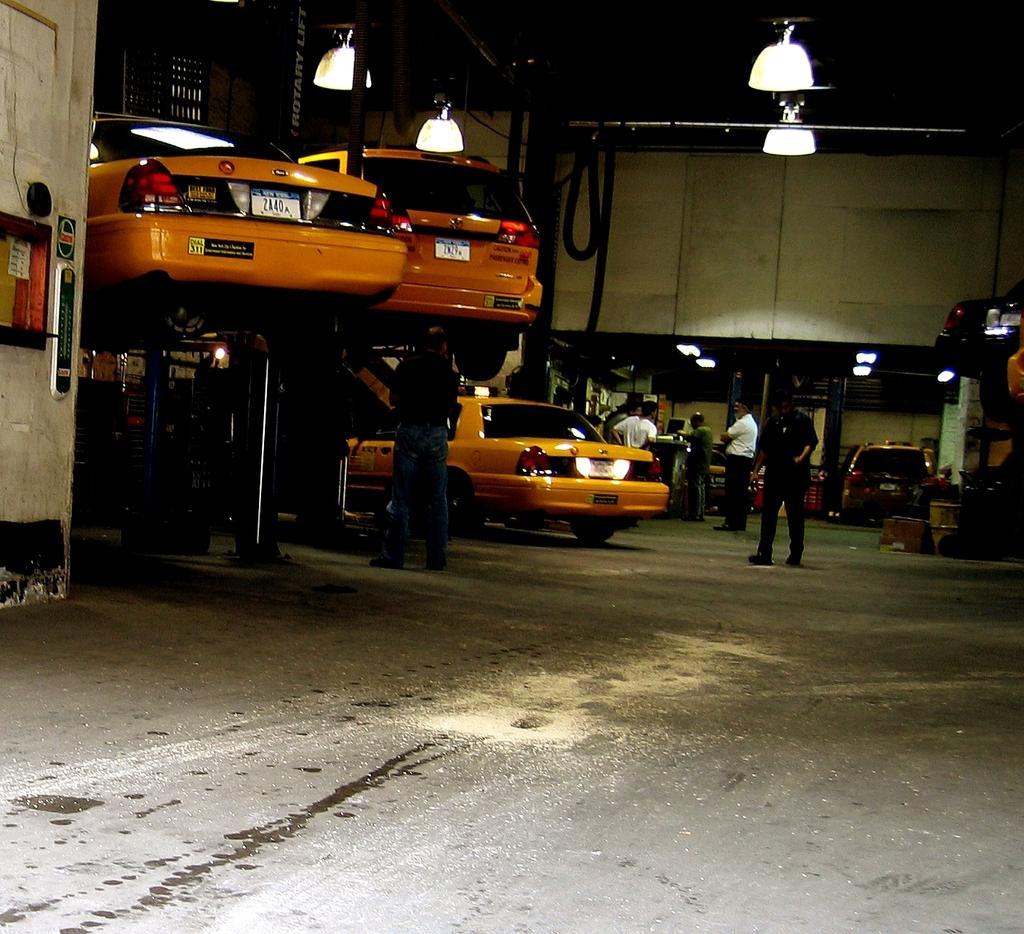In one or two sentences, can you explain what this image depicts? This picture shows few cars and few people standing and we see lights hanging to the ceiling, couple of cars lifted up and picture looks like a garage. 